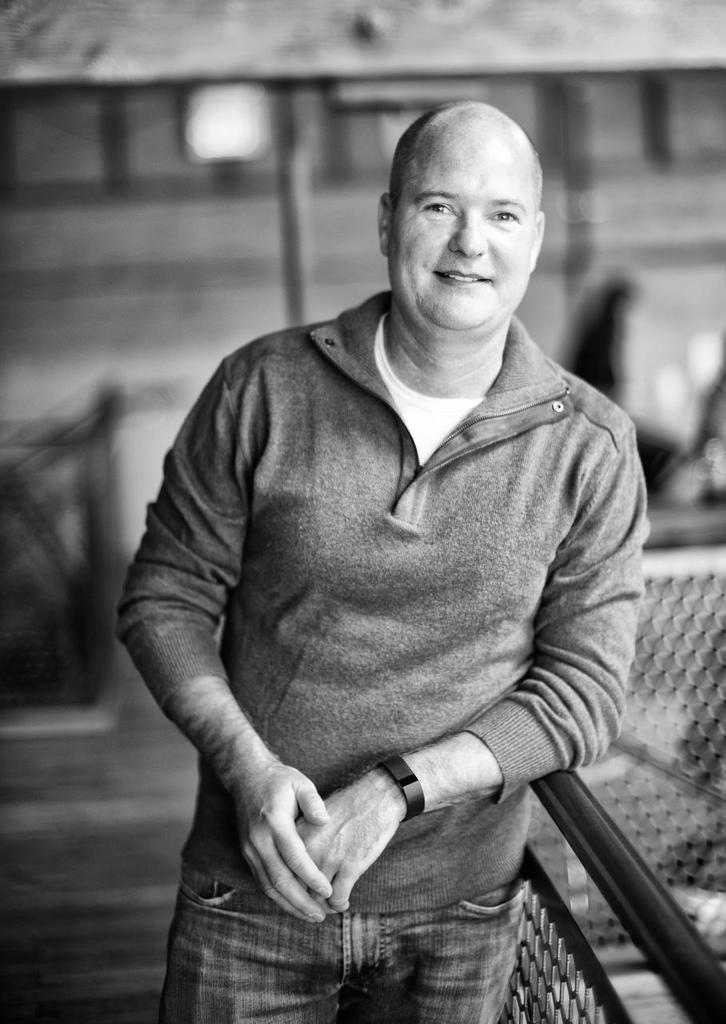In one or two sentences, can you explain what this image depicts? This image consists of a man. At the bottom, there is a road. On the right, we can see a fencing. In the background, there is a building. 